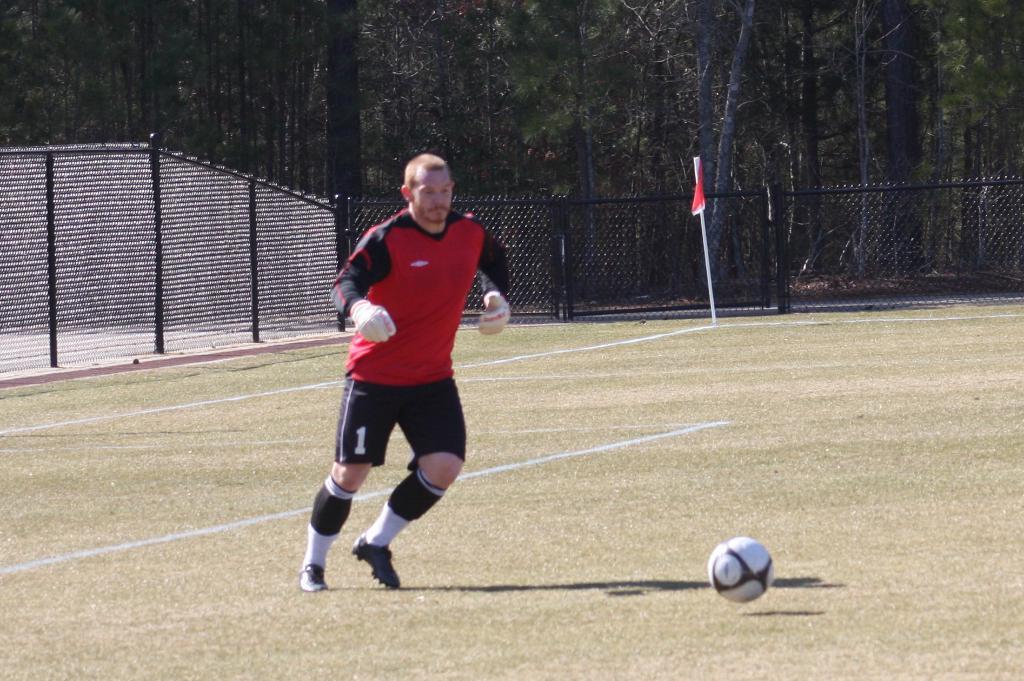Can you describe this image briefly? In this image we can see a person wearing a red color T-shirt. There is a football. In the background of the image there is fencing. There is a flag. There are trees. At the bottom of the image there is grass. 